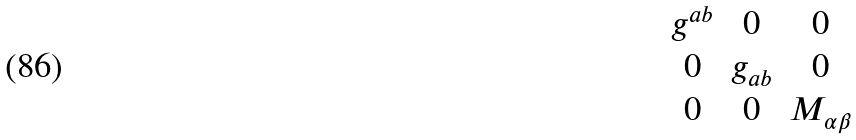Convert formula to latex. <formula><loc_0><loc_0><loc_500><loc_500>\begin{matrix} g ^ { a b } & 0 & 0 \\ 0 & g _ { a b } & 0 \\ 0 & 0 & M _ { \alpha \beta } \end{matrix}</formula> 